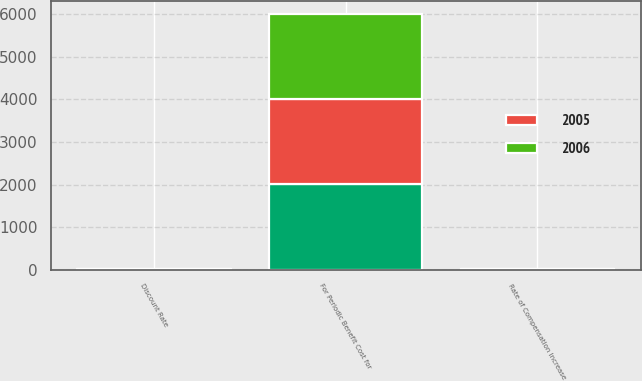Convert chart. <chart><loc_0><loc_0><loc_500><loc_500><stacked_bar_chart><ecel><fcel>For Periodic Benefit Cost for<fcel>Discount Rate<fcel>Rate of Compensation Increase<nl><fcel>nan<fcel>2006<fcel>7<fcel>4.5<nl><fcel>2006<fcel>2005<fcel>7.05<fcel>4.5<nl><fcel>2005<fcel>2004<fcel>7.25<fcel>4.5<nl></chart> 